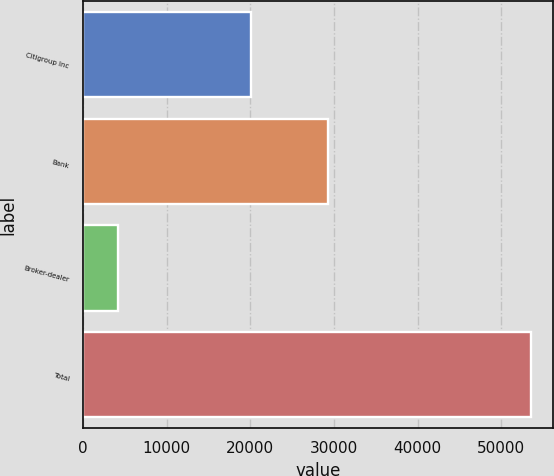Convert chart to OTSL. <chart><loc_0><loc_0><loc_500><loc_500><bar_chart><fcel>Citigroup Inc<fcel>Bank<fcel>Broker-dealer<fcel>Total<nl><fcel>20050<fcel>29270<fcel>4158<fcel>53478<nl></chart> 